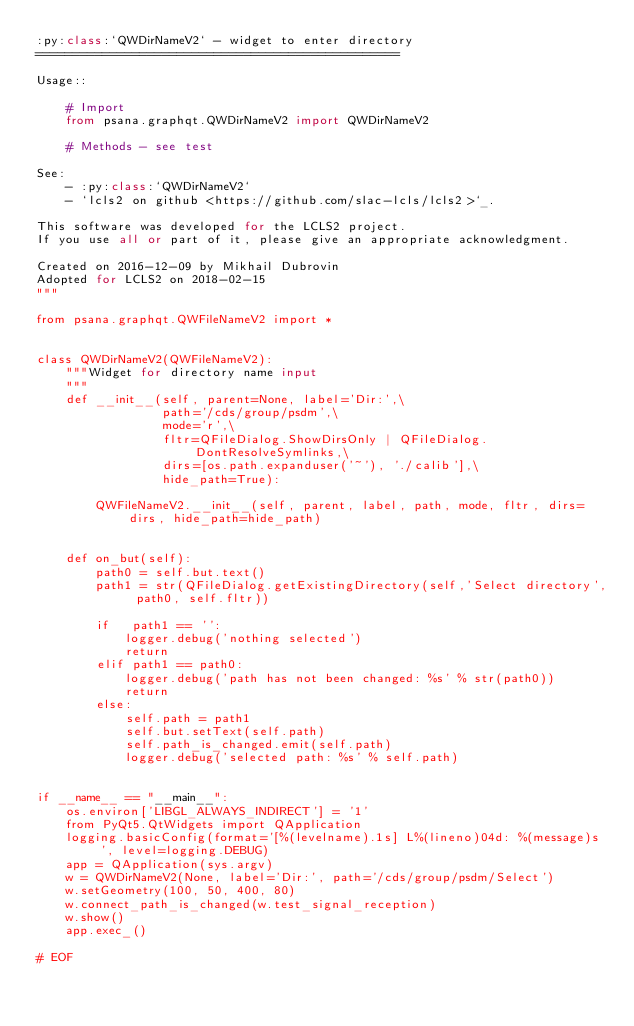<code> <loc_0><loc_0><loc_500><loc_500><_Python_>:py:class:`QWDirNameV2` - widget to enter directory
=================================================

Usage::

    # Import
    from psana.graphqt.QWDirNameV2 import QWDirNameV2

    # Methods - see test

See:
    - :py:class:`QWDirNameV2`
    - `lcls2 on github <https://github.com/slac-lcls/lcls2>`_.

This software was developed for the LCLS2 project.
If you use all or part of it, please give an appropriate acknowledgment.

Created on 2016-12-09 by Mikhail Dubrovin
Adopted for LCLS2 on 2018-02-15
"""

from psana.graphqt.QWFileNameV2 import *


class QWDirNameV2(QWFileNameV2):
    """Widget for directory name input
    """
    def __init__(self, parent=None, label='Dir:',\
                 path='/cds/group/psdm',\
                 mode='r',\
                 fltr=QFileDialog.ShowDirsOnly | QFileDialog.DontResolveSymlinks,\
                 dirs=[os.path.expanduser('~'), './calib'],\
                 hide_path=True):

        QWFileNameV2.__init__(self, parent, label, path, mode, fltr, dirs=dirs, hide_path=hide_path)


    def on_but(self):
        path0 = self.but.text()
        path1 = str(QFileDialog.getExistingDirectory(self,'Select directory', path0, self.fltr))

        if   path1 == '':
            logger.debug('nothing selected')
            return
        elif path1 == path0:
            logger.debug('path has not been changed: %s' % str(path0))
            return
        else:
            self.path = path1
            self.but.setText(self.path)
            self.path_is_changed.emit(self.path)
            logger.debug('selected path: %s' % self.path)


if __name__ == "__main__":
    os.environ['LIBGL_ALWAYS_INDIRECT'] = '1'
    from PyQt5.QtWidgets import QApplication
    logging.basicConfig(format='[%(levelname).1s] L%(lineno)04d: %(message)s', level=logging.DEBUG)
    app = QApplication(sys.argv)
    w = QWDirNameV2(None, label='Dir:', path='/cds/group/psdm/Select')
    w.setGeometry(100, 50, 400, 80)
    w.connect_path_is_changed(w.test_signal_reception)
    w.show()
    app.exec_()

# EOF
</code> 